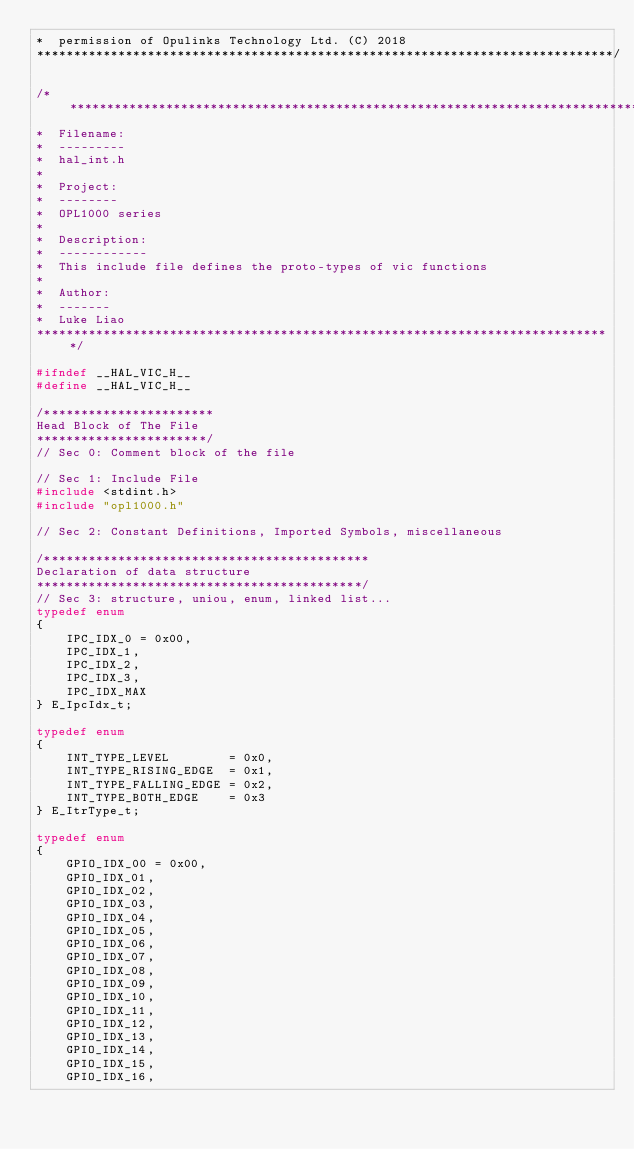Convert code to text. <code><loc_0><loc_0><loc_500><loc_500><_C_>*  permission of Opulinks Technology Ltd. (C) 2018
******************************************************************************/

/******************************************************************************
*  Filename:
*  ---------
*  hal_int.h
*
*  Project:
*  --------
*  OPL1000 series
*
*  Description:
*  ------------
*  This include file defines the proto-types of vic functions
*
*  Author:
*  -------
*  Luke Liao
******************************************************************************/

#ifndef __HAL_VIC_H__
#define __HAL_VIC_H__

/***********************
Head Block of The File
***********************/
// Sec 0: Comment block of the file

// Sec 1: Include File 
#include <stdint.h>
#include "opl1000.h"

// Sec 2: Constant Definitions, Imported Symbols, miscellaneous

/********************************************
Declaration of data structure
********************************************/
// Sec 3: structure, uniou, enum, linked list...
typedef enum 
{
    IPC_IDX_0 = 0x00,
    IPC_IDX_1,
    IPC_IDX_2,
    IPC_IDX_3,
    IPC_IDX_MAX
} E_IpcIdx_t;

typedef enum 
{
    INT_TYPE_LEVEL        = 0x0,
    INT_TYPE_RISING_EDGE  = 0x1,
    INT_TYPE_FALLING_EDGE = 0x2,
    INT_TYPE_BOTH_EDGE    = 0x3
} E_ItrType_t;

typedef enum 
{
    GPIO_IDX_00 = 0x00,
    GPIO_IDX_01,
    GPIO_IDX_02,
    GPIO_IDX_03,
    GPIO_IDX_04,
    GPIO_IDX_05,
    GPIO_IDX_06,
    GPIO_IDX_07,
    GPIO_IDX_08,
    GPIO_IDX_09,
    GPIO_IDX_10,
    GPIO_IDX_11,
    GPIO_IDX_12,
    GPIO_IDX_13,
    GPIO_IDX_14,
    GPIO_IDX_15,
    GPIO_IDX_16,</code> 